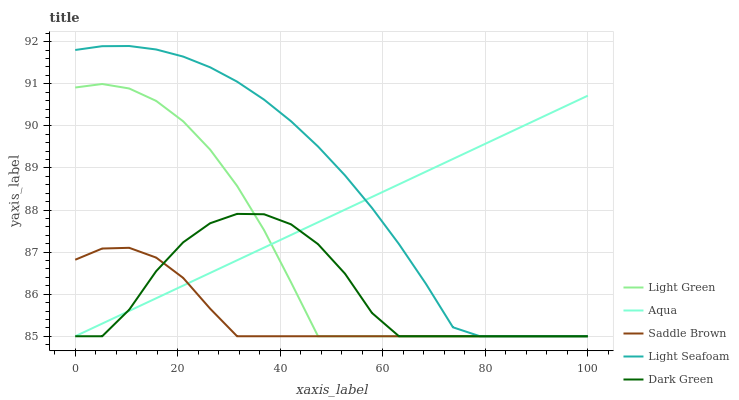Does Saddle Brown have the minimum area under the curve?
Answer yes or no. Yes. Does Light Seafoam have the maximum area under the curve?
Answer yes or no. Yes. Does Aqua have the minimum area under the curve?
Answer yes or no. No. Does Aqua have the maximum area under the curve?
Answer yes or no. No. Is Aqua the smoothest?
Answer yes or no. Yes. Is Dark Green the roughest?
Answer yes or no. Yes. Is Saddle Brown the smoothest?
Answer yes or no. No. Is Saddle Brown the roughest?
Answer yes or no. No. Does Light Seafoam have the lowest value?
Answer yes or no. Yes. Does Light Seafoam have the highest value?
Answer yes or no. Yes. Does Aqua have the highest value?
Answer yes or no. No. Does Dark Green intersect Saddle Brown?
Answer yes or no. Yes. Is Dark Green less than Saddle Brown?
Answer yes or no. No. Is Dark Green greater than Saddle Brown?
Answer yes or no. No. 